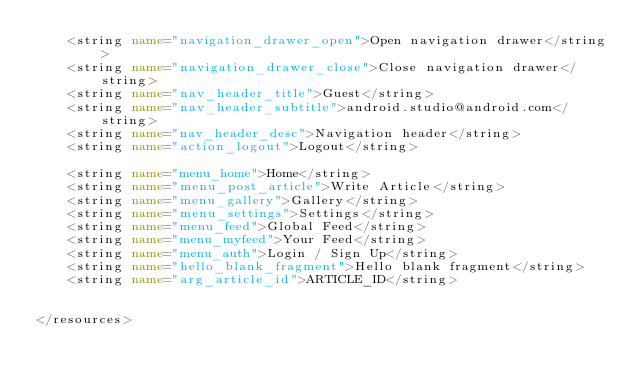Convert code to text. <code><loc_0><loc_0><loc_500><loc_500><_XML_>    <string name="navigation_drawer_open">Open navigation drawer</string>
    <string name="navigation_drawer_close">Close navigation drawer</string>
    <string name="nav_header_title">Guest</string>
    <string name="nav_header_subtitle">android.studio@android.com</string>
    <string name="nav_header_desc">Navigation header</string>
    <string name="action_logout">Logout</string>

    <string name="menu_home">Home</string>
    <string name="menu_post_article">Write Article</string>
    <string name="menu_gallery">Gallery</string>
    <string name="menu_settings">Settings</string>
    <string name="menu_feed">Global Feed</string>
    <string name="menu_myfeed">Your Feed</string>
    <string name="menu_auth">Login / Sign Up</string>
    <string name="hello_blank_fragment">Hello blank fragment</string>
    <string name="arg_article_id">ARTICLE_ID</string>


</resources></code> 